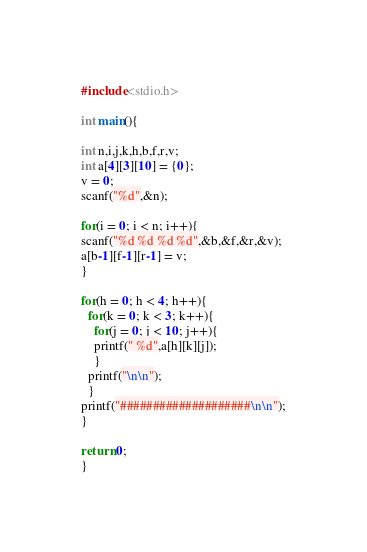Convert code to text. <code><loc_0><loc_0><loc_500><loc_500><_C_>#include<stdio.h>

int main(){

int n,i,j,k,h,b,f,r,v;
int a[4][3][10] = {0};
v = 0;
scanf("%d",&n);

for(i = 0; i < n; i++){
scanf("%d %d %d %d",&b,&f,&r,&v);
a[b-1][f-1][r-1] = v;
}

for(h = 0; h < 4; h++){
  for(k = 0; k < 3; k++){
    for(j = 0; j < 10; j++){
    printf(" %d",a[h][k][j]);
    }
  printf("\n\n");
  }
printf("####################\n\n");
}

return 0;
}
</code> 